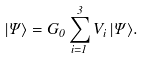<formula> <loc_0><loc_0><loc_500><loc_500>| \Psi \rangle = G _ { 0 } \sum _ { i = 1 } ^ { 3 } V _ { i } \, | \Psi \rangle .</formula> 